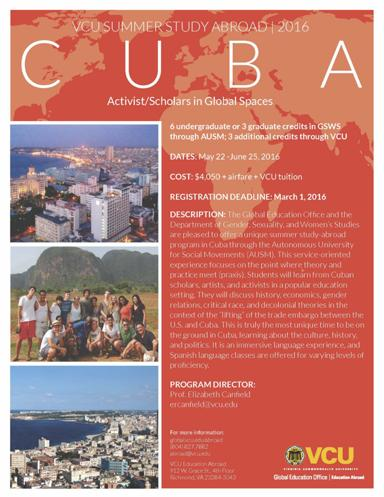Where is the study abroad program taking place? This intriguing study abroad program is located in Cuba, operated in collaboration with the Autonomous University for Social Movements (AUSM). This partnership enhances the learning experience, providing students with a robust framework for understanding global societal issues directly from local perspectives. 